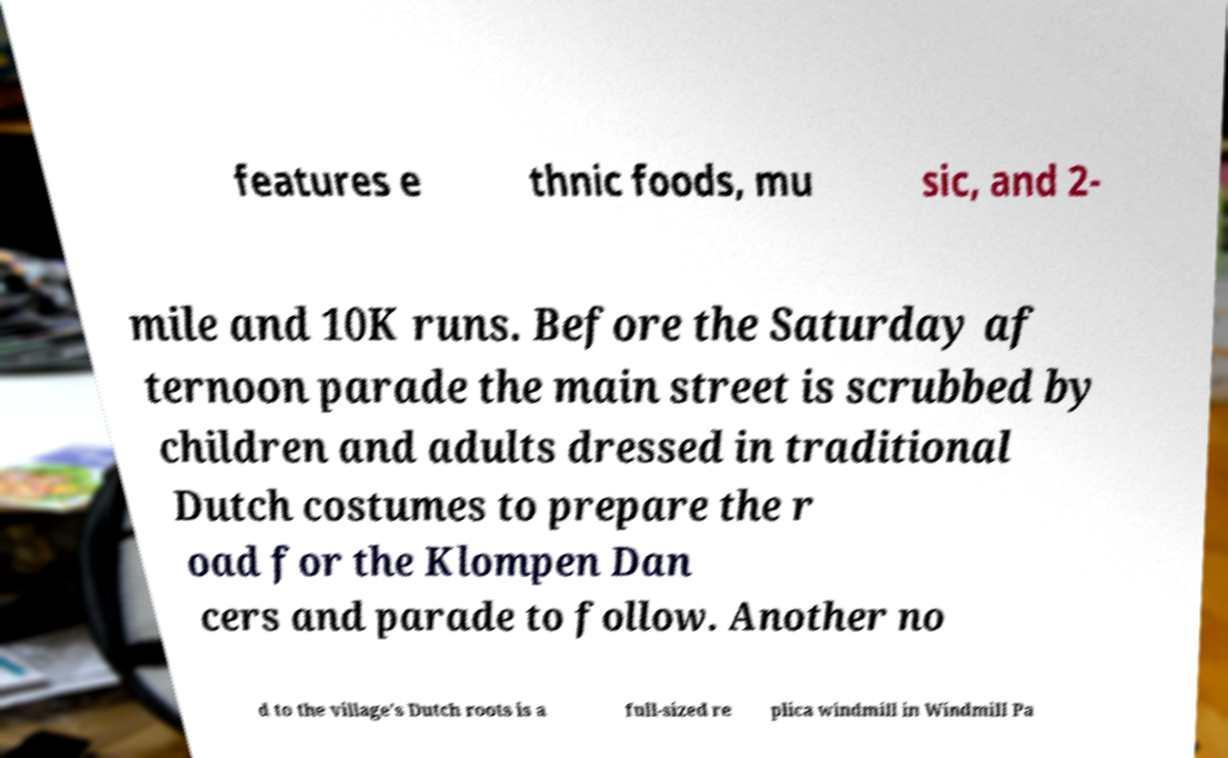Could you extract and type out the text from this image? features e thnic foods, mu sic, and 2- mile and 10K runs. Before the Saturday af ternoon parade the main street is scrubbed by children and adults dressed in traditional Dutch costumes to prepare the r oad for the Klompen Dan cers and parade to follow. Another no d to the village's Dutch roots is a full-sized re plica windmill in Windmill Pa 